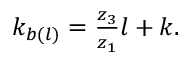<formula> <loc_0><loc_0><loc_500><loc_500>\begin{array} { r } { k _ { b ( l ) } = \frac { z _ { 3 } } { z _ { 1 } } l + k . } \end{array}</formula> 